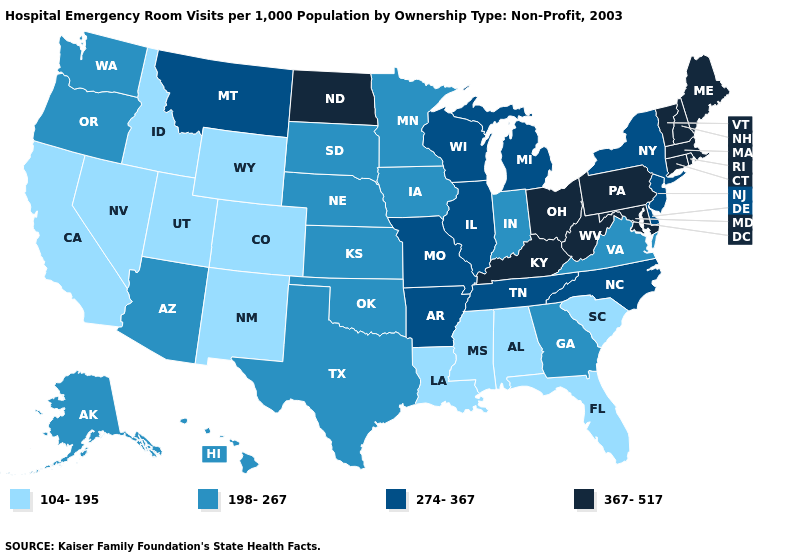Does Wyoming have the highest value in the West?
Be succinct. No. Name the states that have a value in the range 367-517?
Be succinct. Connecticut, Kentucky, Maine, Maryland, Massachusetts, New Hampshire, North Dakota, Ohio, Pennsylvania, Rhode Island, Vermont, West Virginia. Which states hav the highest value in the West?
Concise answer only. Montana. Name the states that have a value in the range 104-195?
Give a very brief answer. Alabama, California, Colorado, Florida, Idaho, Louisiana, Mississippi, Nevada, New Mexico, South Carolina, Utah, Wyoming. What is the value of Ohio?
Be succinct. 367-517. What is the value of Virginia?
Concise answer only. 198-267. Name the states that have a value in the range 274-367?
Short answer required. Arkansas, Delaware, Illinois, Michigan, Missouri, Montana, New Jersey, New York, North Carolina, Tennessee, Wisconsin. What is the lowest value in the MidWest?
Answer briefly. 198-267. Does Louisiana have the highest value in the USA?
Answer briefly. No. Does Ohio have the same value as New York?
Answer briefly. No. Does Pennsylvania have the highest value in the USA?
Give a very brief answer. Yes. What is the lowest value in states that border Maryland?
Quick response, please. 198-267. Among the states that border Vermont , does Massachusetts have the lowest value?
Concise answer only. No. How many symbols are there in the legend?
Short answer required. 4. What is the lowest value in the USA?
Answer briefly. 104-195. 